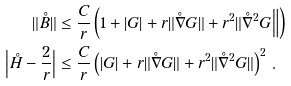Convert formula to latex. <formula><loc_0><loc_0><loc_500><loc_500>\| \mathring { B } \| & \leq \frac { C } { r } \left ( 1 + | G | + r \| \mathring { \nabla } G \| + r ^ { 2 } \| \mathring { \nabla } ^ { 2 } G \Big \| \right ) \\ \Big | \mathring { H } - \frac { 2 } { r } \Big | & \leq \frac { C } { r } \left ( | G | + r \| \mathring { \nabla } G \| + r ^ { 2 } \| \mathring { \nabla } ^ { 2 } G \| \right ) ^ { 2 } \, .</formula> 